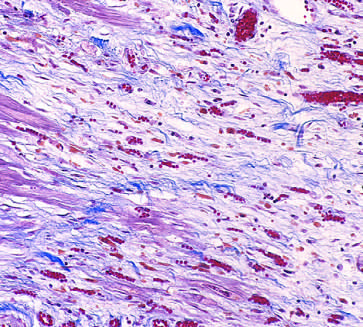re proadiposity signals present?
Answer the question using a single word or phrase. No 